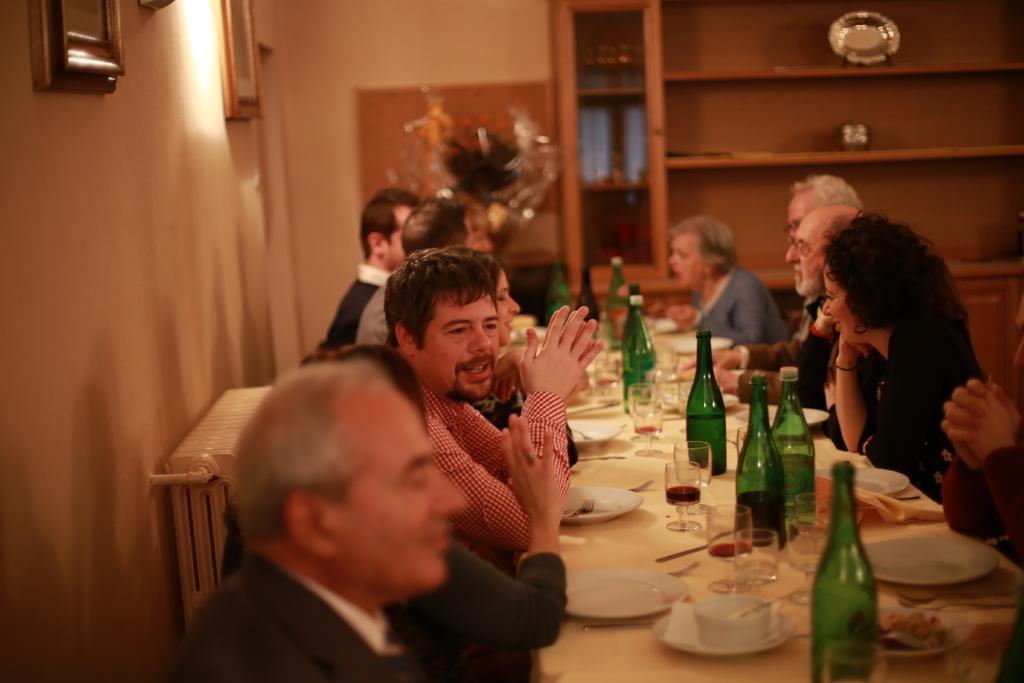How would you summarize this image in a sentence or two? This is a picture taken in a room, there are a group of people sitting on a chair in front of these people there is a table on the table there are plate, cup, glasses, spoon and bottles. Background of these people is a wall with photo frames. 